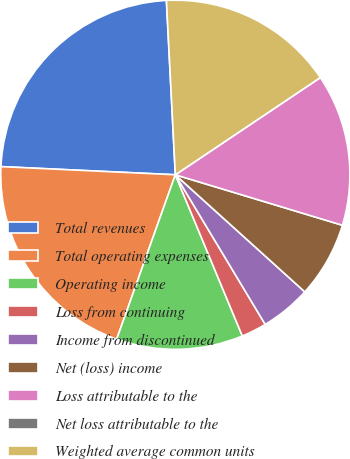Convert chart. <chart><loc_0><loc_0><loc_500><loc_500><pie_chart><fcel>Total revenues<fcel>Total operating expenses<fcel>Operating income<fcel>Loss from continuing<fcel>Income from discontinued<fcel>Net (loss) income<fcel>Loss attributable to the<fcel>Net loss attributable to the<fcel>Weighted average common units<nl><fcel>23.44%<fcel>20.29%<fcel>11.72%<fcel>2.34%<fcel>4.69%<fcel>7.03%<fcel>14.07%<fcel>0.0%<fcel>16.41%<nl></chart> 